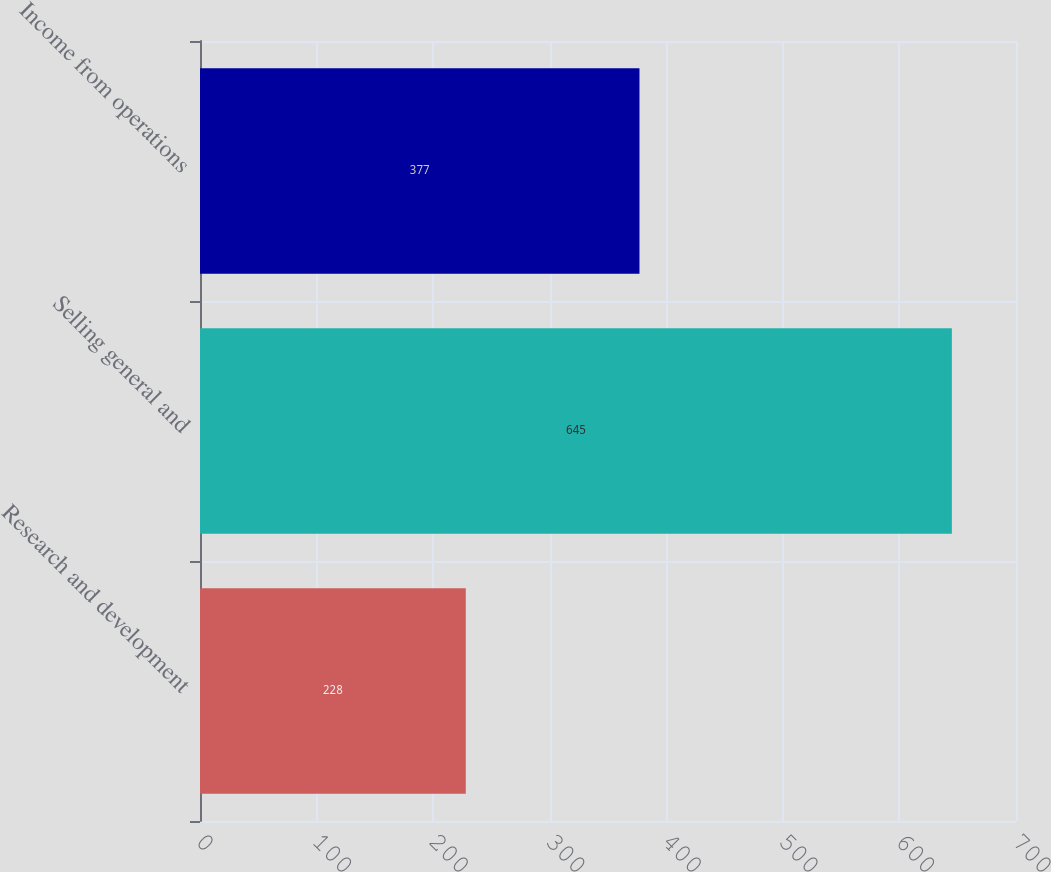Convert chart to OTSL. <chart><loc_0><loc_0><loc_500><loc_500><bar_chart><fcel>Research and development<fcel>Selling general and<fcel>Income from operations<nl><fcel>228<fcel>645<fcel>377<nl></chart> 